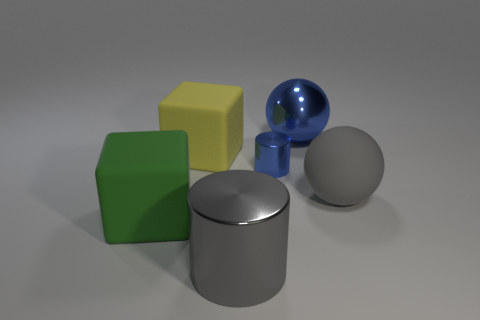Can you guess the weights of the objects by their appearances? While I cannot precisely measure their weights, based on their appearances and assuming they are made from typical materials, the green and yellow cubes likely weigh less than the metallic cylinder and sphere due to the density differences between rubber or plastic and metal. The grey sphere seems similar in weight to the metallic objects if it's made from a dense material. 